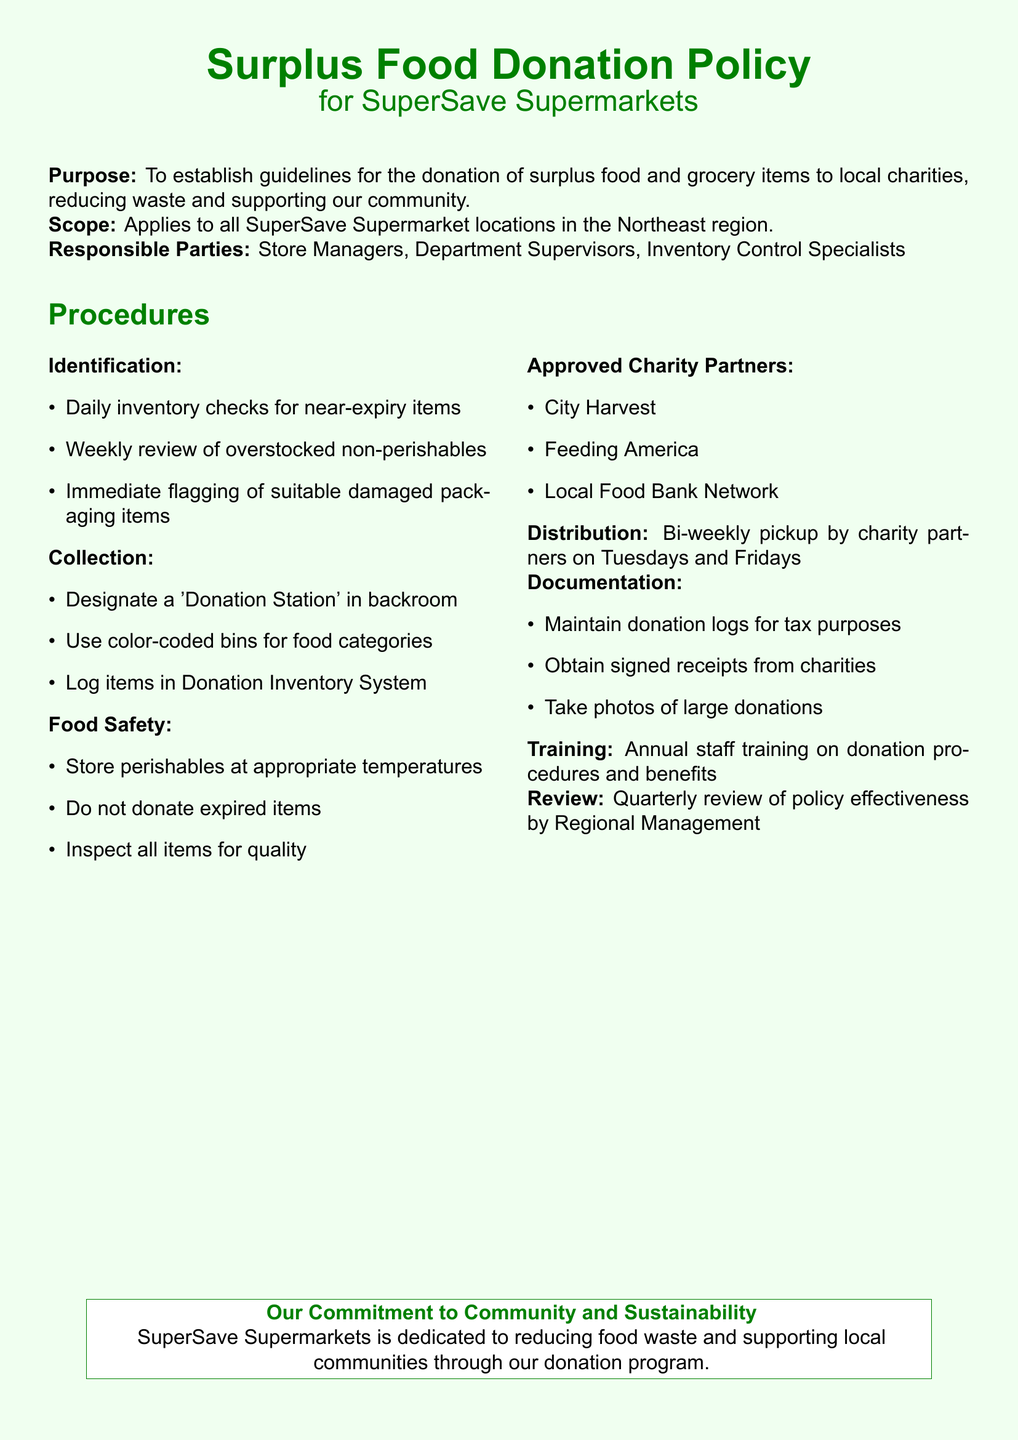what is the purpose of the policy? The purpose is stated clearly at the beginning of the document, which is to establish guidelines for the donation of surplus food and grocery items.
Answer: To establish guidelines for the donation of surplus food and grocery items who is responsible for the donation procedures? The Responsible Parties section lists the roles accountable for the procedures, including Store Managers, Department Supervisors, and Inventory Control Specialists.
Answer: Store Managers, Department Supervisors, Inventory Control Specialists how often are donation pickups scheduled? The Distribution section specifies the frequency of pickups by charity partners.
Answer: Bi-weekly what items should be immediately flagged? The Identification section mentions specifically what should be flagged when suitable, which includes items with damaged packaging.
Answer: Suitable damaged packaging items which organizations are listed as approved charity partners? The Approved Charity Partners section provides the names of the charities included in the policy.
Answer: City Harvest, Feeding America, Local Food Bank Network what must be maintained for tax purposes? The Documentation section specifies what needs to be kept for tax purposes.
Answer: Donation logs how frequently is the policy reviewed? The Review section discusses how often the effectiveness of the policy is evaluated.
Answer: Quarterly what type of food items should not be donated? The Food Safety section clarifies specifically what items are prohibited for donation.
Answer: Expired items what kind of training is provided to staff? The Training section outlines the type of training offered regarding the program and its benefits.
Answer: Annual staff training 